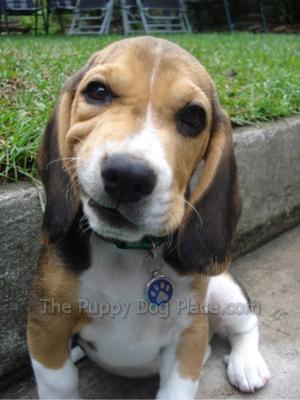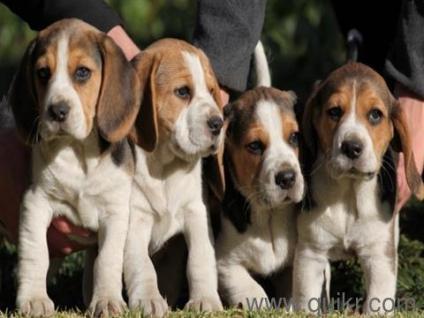The first image is the image on the left, the second image is the image on the right. For the images shown, is this caption "Each image contains one dog, and one image shows a sitting puppy while the other shows a tri-color beagle wearing something around its neck." true? Answer yes or no. No. The first image is the image on the left, the second image is the image on the right. Analyze the images presented: Is the assertion "Exactly one dog in the right image is standing." valid? Answer yes or no. No. 